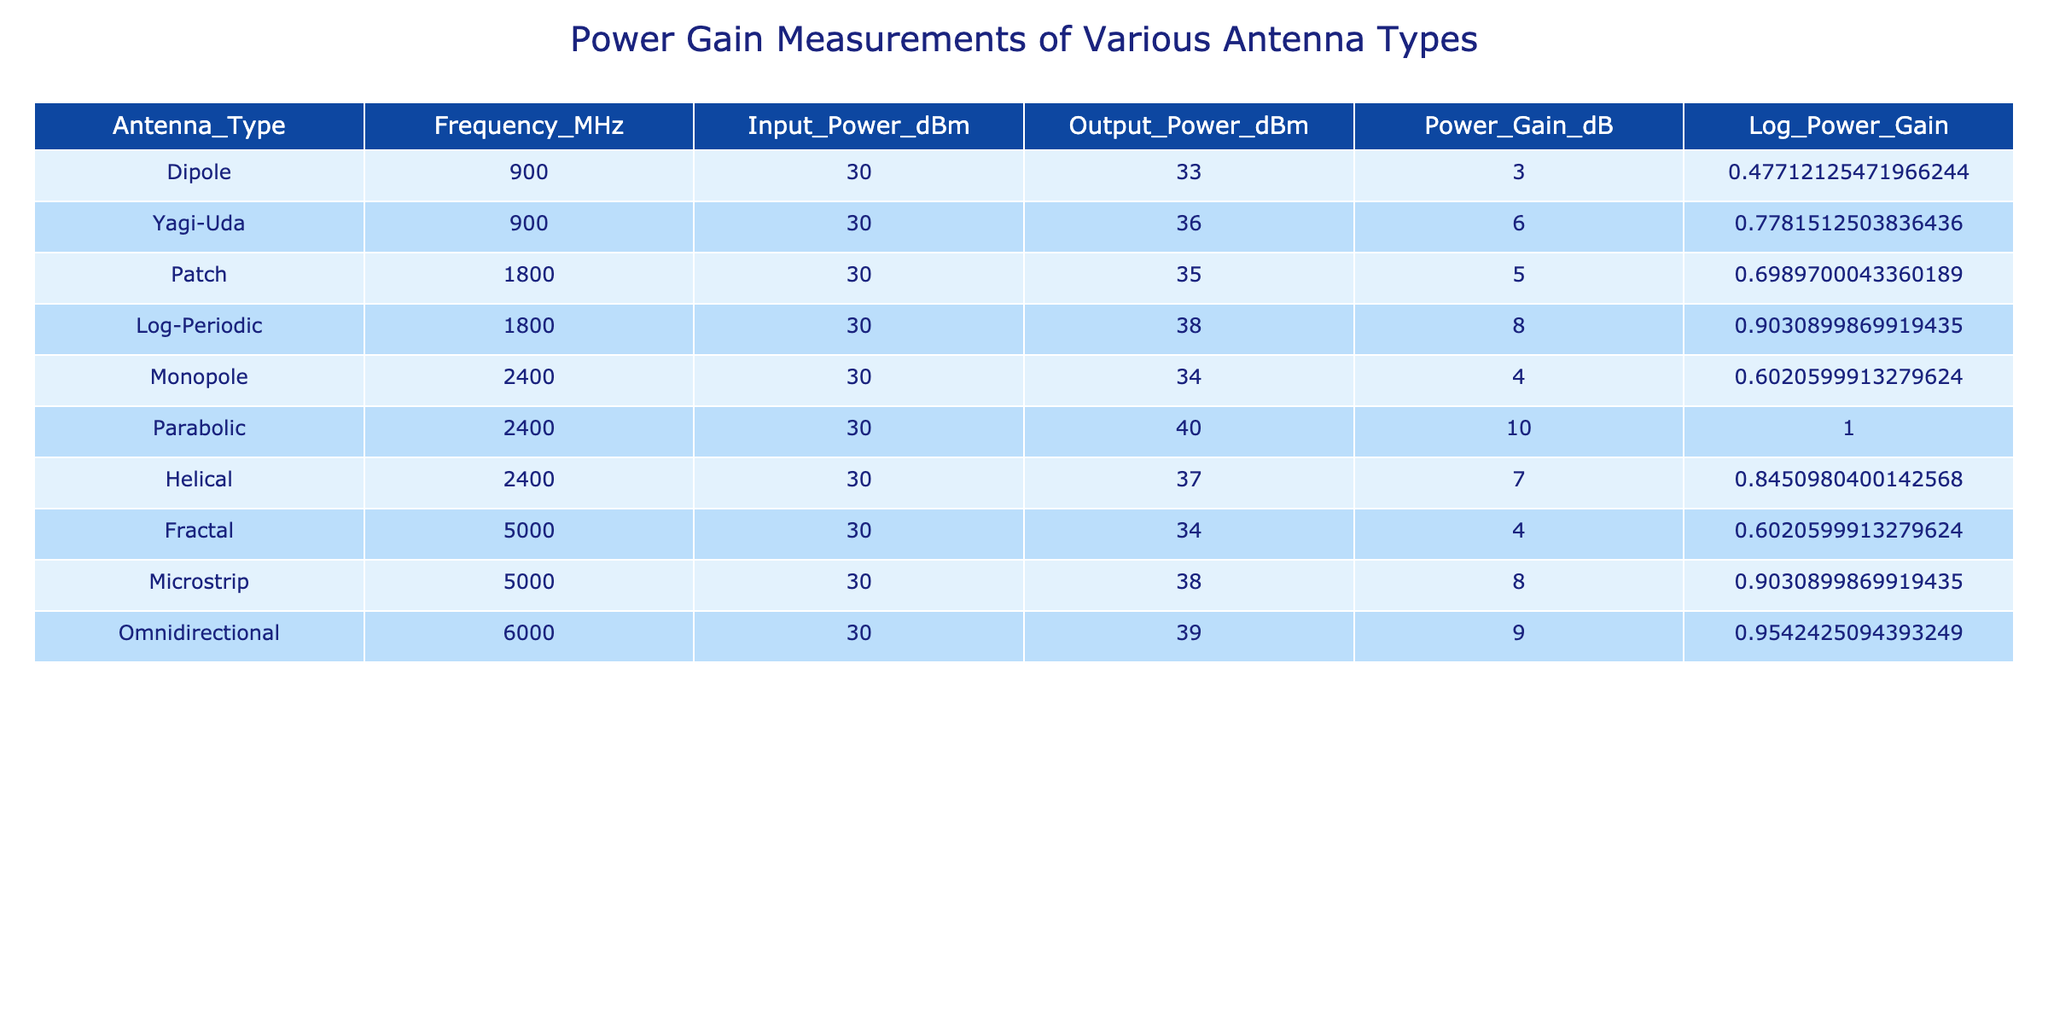What is the Power Gain in dB of the Yagi-Uda antenna? The table indicates that the Power Gain for the Yagi-Uda antenna is shown in the column "Power_Gain_dB", which reads 6.
Answer: 6 What is the frequency (in MHz) at which the Patch antenna operates? Looking at the "Frequency_MHz" column for the Patch antenna, it is listed as operating at 1800 MHz.
Answer: 1800 Is the Parabolic antenna's Power Gain higher than the Dipole antenna's? The Power Gain for the Parabolic antenna is 10 dB, while for the Dipole antenna it is 3 dB. Since 10 is greater than 3, the Parabolic antenna indeed has a higher Power Gain.
Answer: Yes What is the average Power Gain (in dB) of the antennas operating at 2400 MHz? The antennas operating at 2400 MHz are the Monopole (4 dB), Parabolic (10 dB), and Helical (7 dB). Adding these gains gives 4 + 10 + 7 = 21 dB. Dividing by the number of antennas (3), the average is 21/3 = 7 dB.
Answer: 7 What is the difference in Power Gain (in dB) between the Omnidirectional and Fractal antennas? The Power Gain for the Omnidirectional is 9 dB, and for the Fractal, it is 4 dB. Therefore, the difference is calculated as 9 - 4 = 5 dB.
Answer: 5 Which antenna type has the maximum Power Gain, and what is that value? Looking through the "Power_Gain_dB" column, the Parabolic antenna has the maximum Power Gain listed at 10 dB, which is higher than all other antennas in the table.
Answer: Parabolic, 10 Are there any antennas with identical Power Gain values in the table? By reviewing the "Power_Gain_dB" column closely, we note that both the Microstrip and Log-Periodic antennas have a Power Gain of 8 dB. Therefore, there are antennas with identical Power Gain values.
Answer: Yes Which antenna type exhibits the least Power Gain, and what is that gain? Scanning the "Power_Gain_dB" column, the Dipole antenna shows the least gain at 3 dB, making it the antenna with the lowest Power Gain in the table.
Answer: Dipole, 3 What is the total Power Gain (in dB) when adding the gains of the Log-Periodic and Monopole antennas? The Power Gain for the Log-Periodic antenna is 8 dB, and for the Monopole, it is 4 dB. Adding these together gives 8 + 4 = 12 dB as the total Power Gain.
Answer: 12 